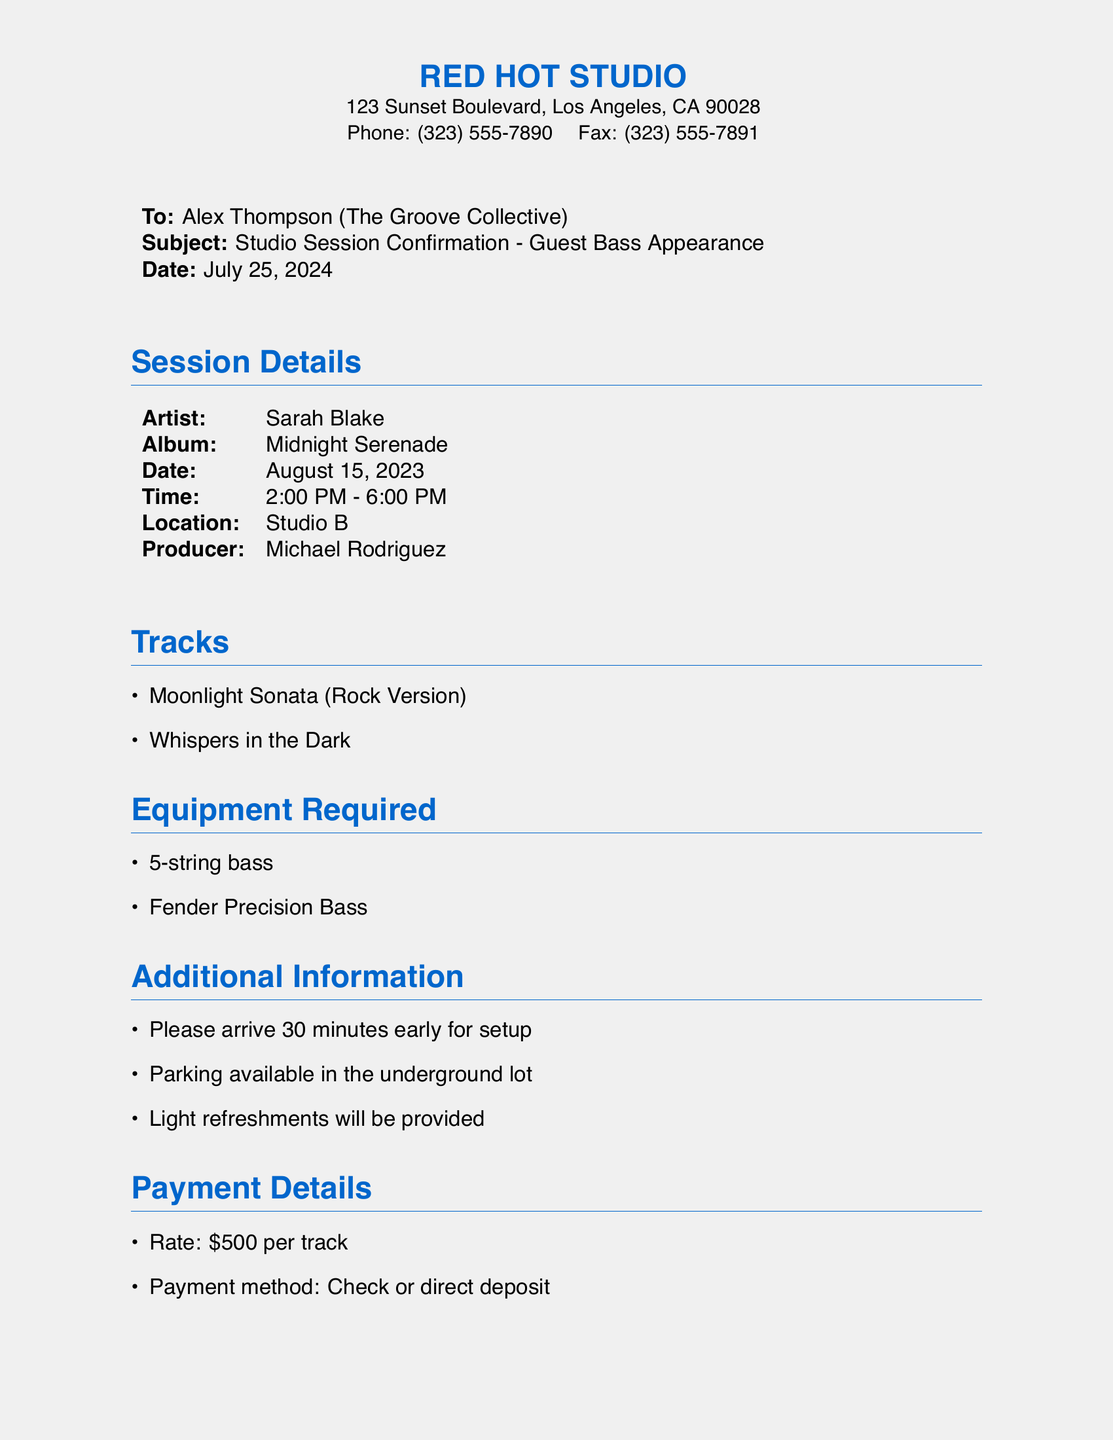What is the date of the studio session? The date of the studio session is explicitly mentioned in the document.
Answer: August 15, 2023 Who is the producer for the session? The producer's name is provided in the session details section.
Answer: Michael Rodriguez What equipment is required? The document outlines the necessary equipment for the recording session.
Answer: 5-string bass, Fender Precision Bass How many tracks will be recorded? The number of tracks can be counted from the list provided in the document.
Answer: 2 tracks What time does the session start? The starting time for the session is listed under the session details.
Answer: 2:00 PM What is the payment rate per track? The payment details specify the rate for each track in the session.
Answer: $500 per track What should you do to confirm your attendance? The document includes instructions on how to confirm attendance.
Answer: Reply to this fax or call Will refreshments be provided? Additional information in the document confirms the provision of refreshments.
Answer: Yes, light refreshments will be provided 